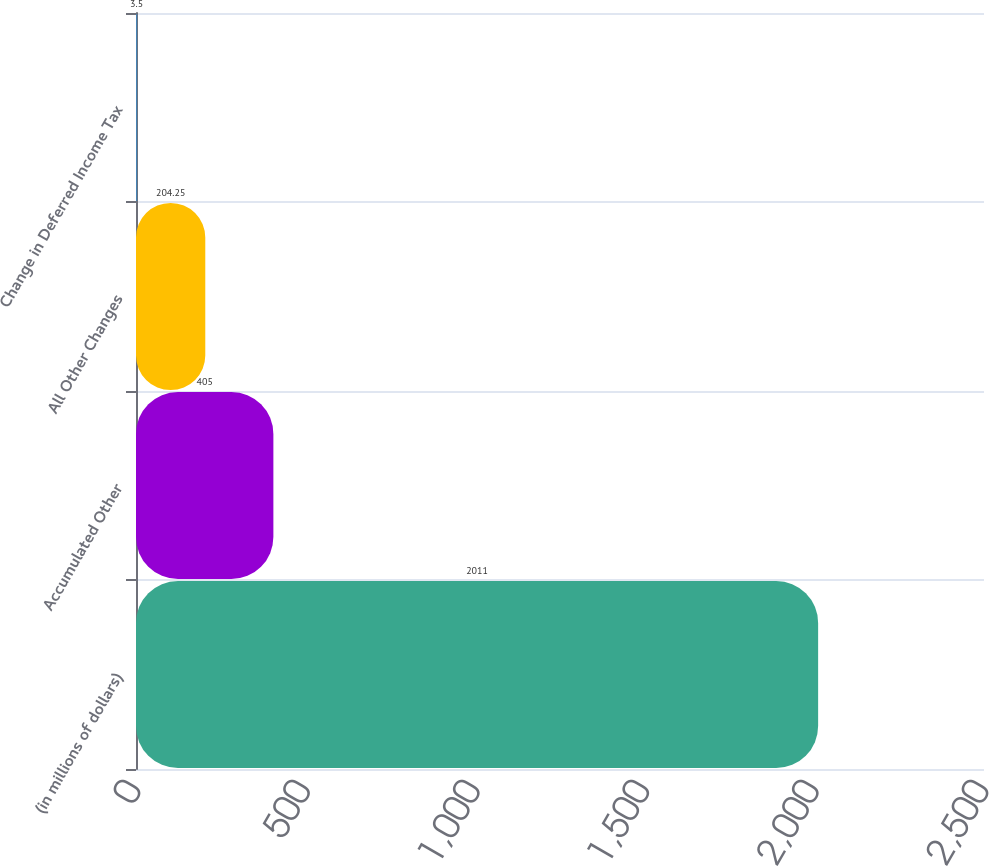<chart> <loc_0><loc_0><loc_500><loc_500><bar_chart><fcel>(in millions of dollars)<fcel>Accumulated Other<fcel>All Other Changes<fcel>Change in Deferred Income Tax<nl><fcel>2011<fcel>405<fcel>204.25<fcel>3.5<nl></chart> 